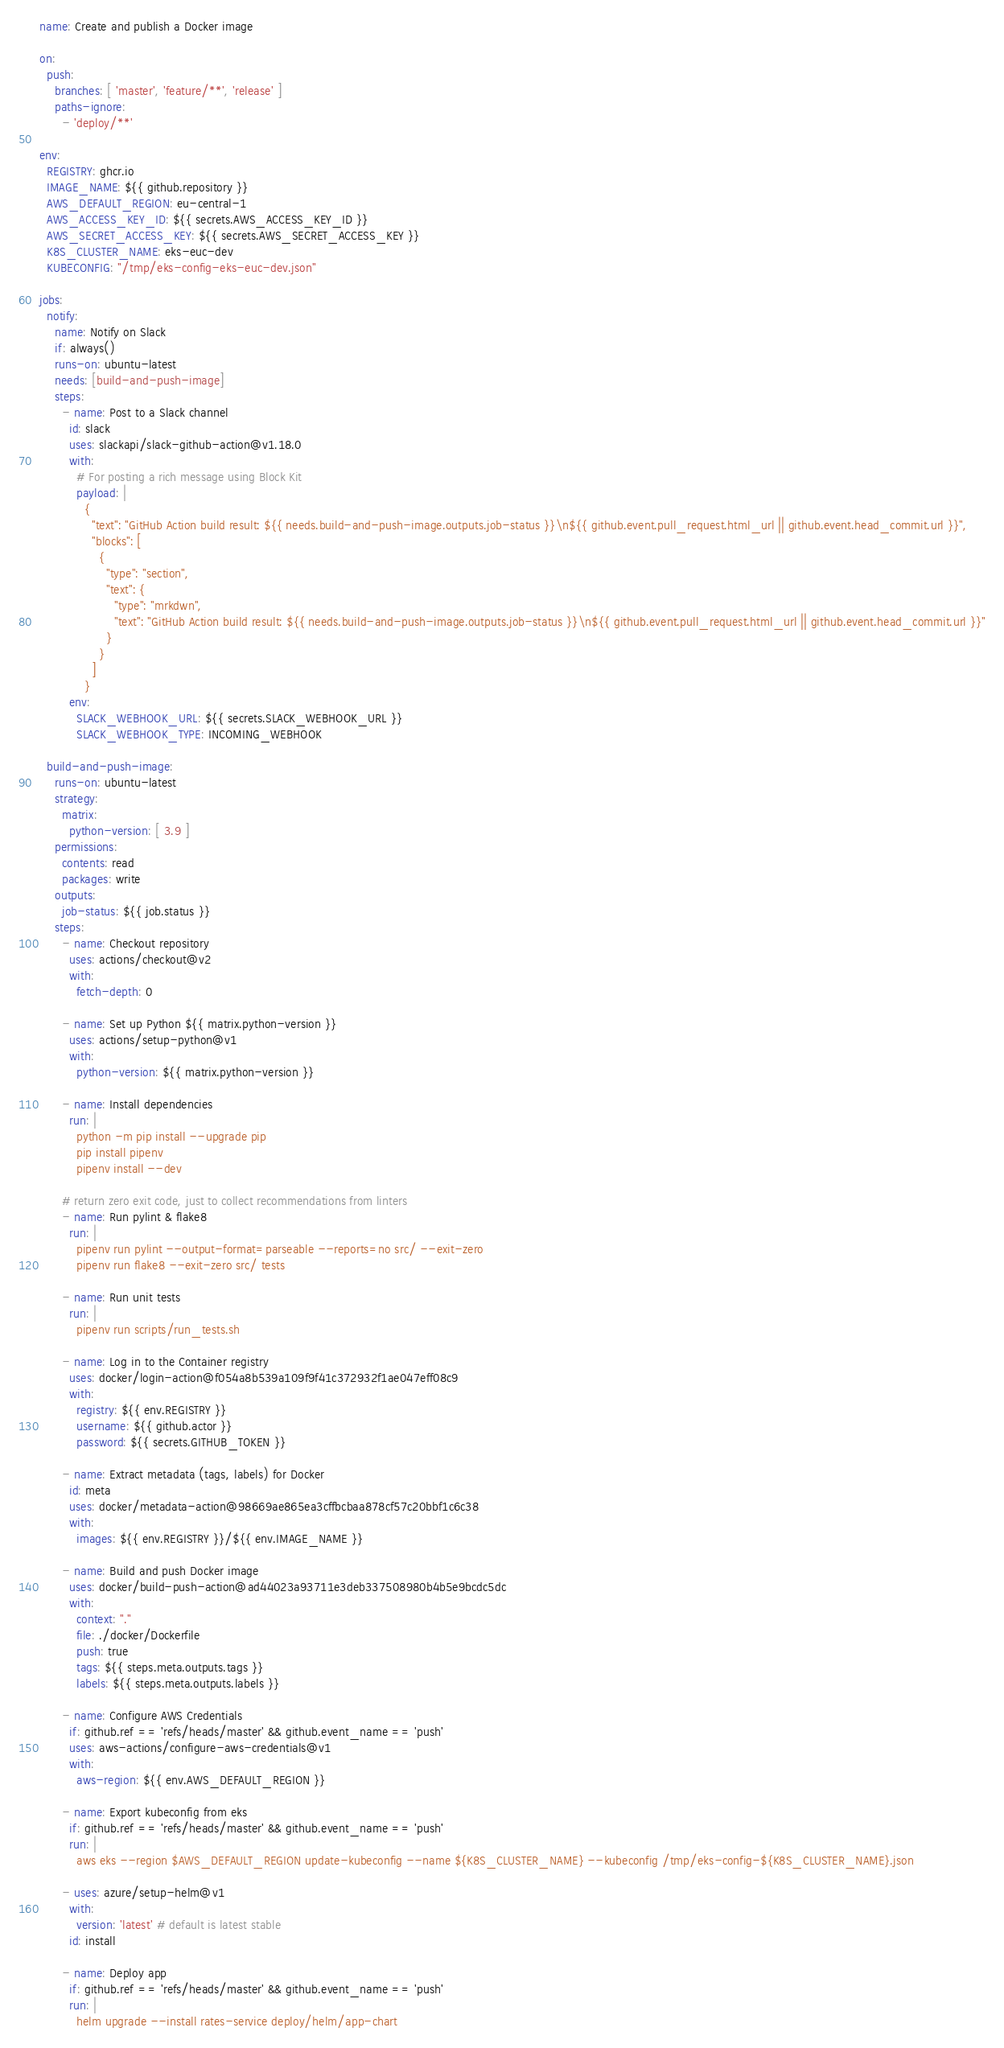Convert code to text. <code><loc_0><loc_0><loc_500><loc_500><_YAML_>name: Create and publish a Docker image

on:
  push:
    branches: [ 'master', 'feature/**', 'release' ]
    paths-ignore:
      - 'deploy/**'

env:
  REGISTRY: ghcr.io
  IMAGE_NAME: ${{ github.repository }}
  AWS_DEFAULT_REGION: eu-central-1
  AWS_ACCESS_KEY_ID: ${{ secrets.AWS_ACCESS_KEY_ID }}
  AWS_SECRET_ACCESS_KEY: ${{ secrets.AWS_SECRET_ACCESS_KEY }}
  K8S_CLUSTER_NAME: eks-euc-dev
  KUBECONFIG: "/tmp/eks-config-eks-euc-dev.json"

jobs:
  notify:
    name: Notify on Slack
    if: always()
    runs-on: ubuntu-latest
    needs: [build-and-push-image]
    steps:
      - name: Post to a Slack channel
        id: slack
        uses: slackapi/slack-github-action@v1.18.0
        with:
          # For posting a rich message using Block Kit
          payload: |
            {
              "text": "GitHub Action build result: ${{ needs.build-and-push-image.outputs.job-status }}\n${{ github.event.pull_request.html_url || github.event.head_commit.url }}",
              "blocks": [
                {
                  "type": "section",
                  "text": {
                    "type": "mrkdwn",
                    "text": "GitHub Action build result: ${{ needs.build-and-push-image.outputs.job-status }}\n${{ github.event.pull_request.html_url || github.event.head_commit.url }}"
                  }
                }
              ]
            }
        env:
          SLACK_WEBHOOK_URL: ${{ secrets.SLACK_WEBHOOK_URL }}
          SLACK_WEBHOOK_TYPE: INCOMING_WEBHOOK

  build-and-push-image:
    runs-on: ubuntu-latest
    strategy:
      matrix:
        python-version: [ 3.9 ]
    permissions:
      contents: read
      packages: write
    outputs:
      job-status: ${{ job.status }}
    steps:
      - name: Checkout repository
        uses: actions/checkout@v2
        with:
          fetch-depth: 0

      - name: Set up Python ${{ matrix.python-version }}
        uses: actions/setup-python@v1
        with:
          python-version: ${{ matrix.python-version }}

      - name: Install dependencies
        run: |
          python -m pip install --upgrade pip
          pip install pipenv
          pipenv install --dev

      # return zero exit code, just to collect recommendations from linters
      - name: Run pylint & flake8
        run: |
          pipenv run pylint --output-format=parseable --reports=no src/ --exit-zero
          pipenv run flake8 --exit-zero src/ tests

      - name: Run unit tests
        run: |
          pipenv run scripts/run_tests.sh

      - name: Log in to the Container registry
        uses: docker/login-action@f054a8b539a109f9f41c372932f1ae047eff08c9
        with:
          registry: ${{ env.REGISTRY }}
          username: ${{ github.actor }}
          password: ${{ secrets.GITHUB_TOKEN }}

      - name: Extract metadata (tags, labels) for Docker
        id: meta
        uses: docker/metadata-action@98669ae865ea3cffbcbaa878cf57c20bbf1c6c38
        with:
          images: ${{ env.REGISTRY }}/${{ env.IMAGE_NAME }}

      - name: Build and push Docker image
        uses: docker/build-push-action@ad44023a93711e3deb337508980b4b5e9bcdc5dc
        with:
          context: "."
          file: ./docker/Dockerfile
          push: true
          tags: ${{ steps.meta.outputs.tags }}
          labels: ${{ steps.meta.outputs.labels }}

      - name: Configure AWS Credentials
        if: github.ref == 'refs/heads/master' && github.event_name == 'push'
        uses: aws-actions/configure-aws-credentials@v1
        with:
          aws-region: ${{ env.AWS_DEFAULT_REGION }}

      - name: Export kubeconfig from eks
        if: github.ref == 'refs/heads/master' && github.event_name == 'push'
        run: |
          aws eks --region $AWS_DEFAULT_REGION update-kubeconfig --name ${K8S_CLUSTER_NAME} --kubeconfig /tmp/eks-config-${K8S_CLUSTER_NAME}.json

      - uses: azure/setup-helm@v1
        with:
          version: 'latest' # default is latest stable
        id: install

      - name: Deploy app
        if: github.ref == 'refs/heads/master' && github.event_name == 'push'
        run: |
          helm upgrade --install rates-service deploy/helm/app-chart
</code> 